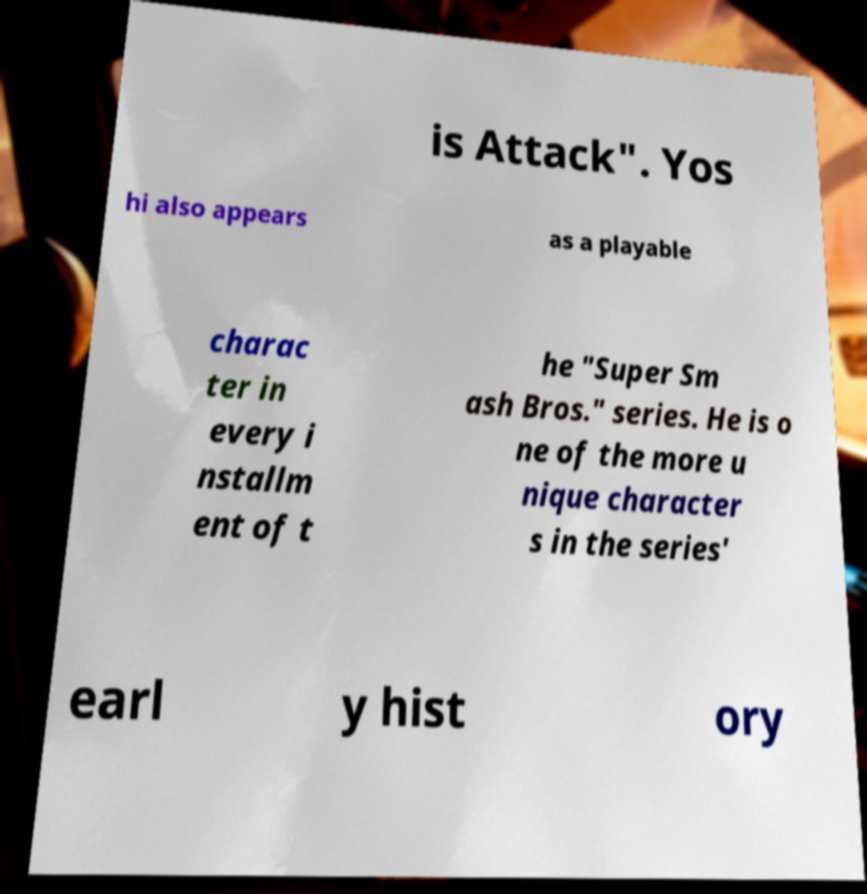Please read and relay the text visible in this image. What does it say? is Attack". Yos hi also appears as a playable charac ter in every i nstallm ent of t he "Super Sm ash Bros." series. He is o ne of the more u nique character s in the series' earl y hist ory 